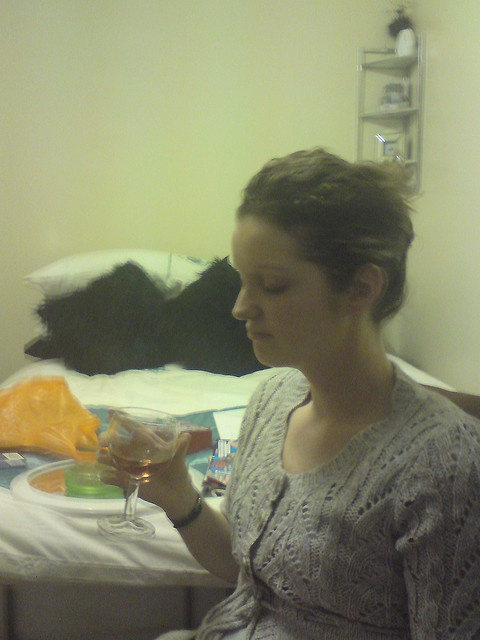Describe the objects in this image and their specific colors. I can see people in darkgray, gray, darkgreen, and black tones, bed in darkgray, beige, gray, and olive tones, and wine glass in darkgray and gray tones in this image. 